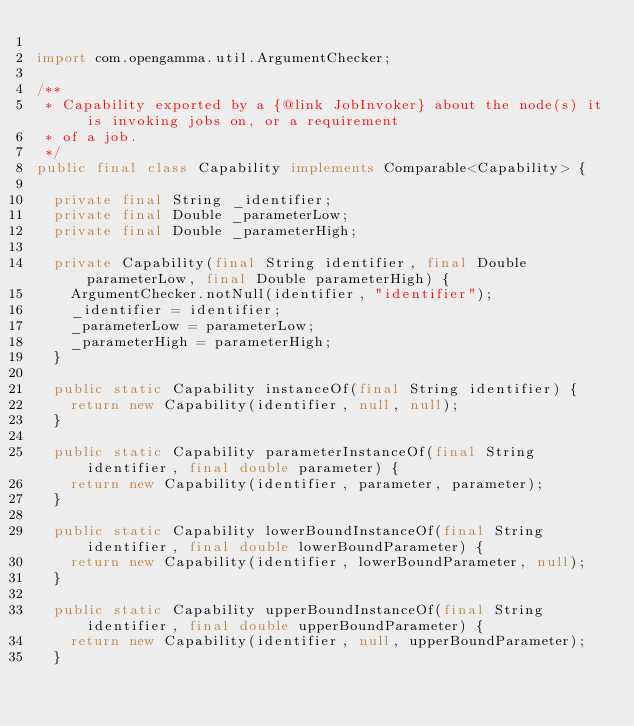Convert code to text. <code><loc_0><loc_0><loc_500><loc_500><_Java_>
import com.opengamma.util.ArgumentChecker;

/**
 * Capability exported by a {@link JobInvoker} about the node(s) it is invoking jobs on, or a requirement
 * of a job.
 */
public final class Capability implements Comparable<Capability> {

  private final String _identifier;
  private final Double _parameterLow;
  private final Double _parameterHigh;

  private Capability(final String identifier, final Double parameterLow, final Double parameterHigh) {
    ArgumentChecker.notNull(identifier, "identifier");
    _identifier = identifier;
    _parameterLow = parameterLow;
    _parameterHigh = parameterHigh;
  }

  public static Capability instanceOf(final String identifier) {
    return new Capability(identifier, null, null);
  }

  public static Capability parameterInstanceOf(final String identifier, final double parameter) {
    return new Capability(identifier, parameter, parameter);
  }

  public static Capability lowerBoundInstanceOf(final String identifier, final double lowerBoundParameter) {
    return new Capability(identifier, lowerBoundParameter, null);
  }

  public static Capability upperBoundInstanceOf(final String identifier, final double upperBoundParameter) {
    return new Capability(identifier, null, upperBoundParameter);
  }
</code> 